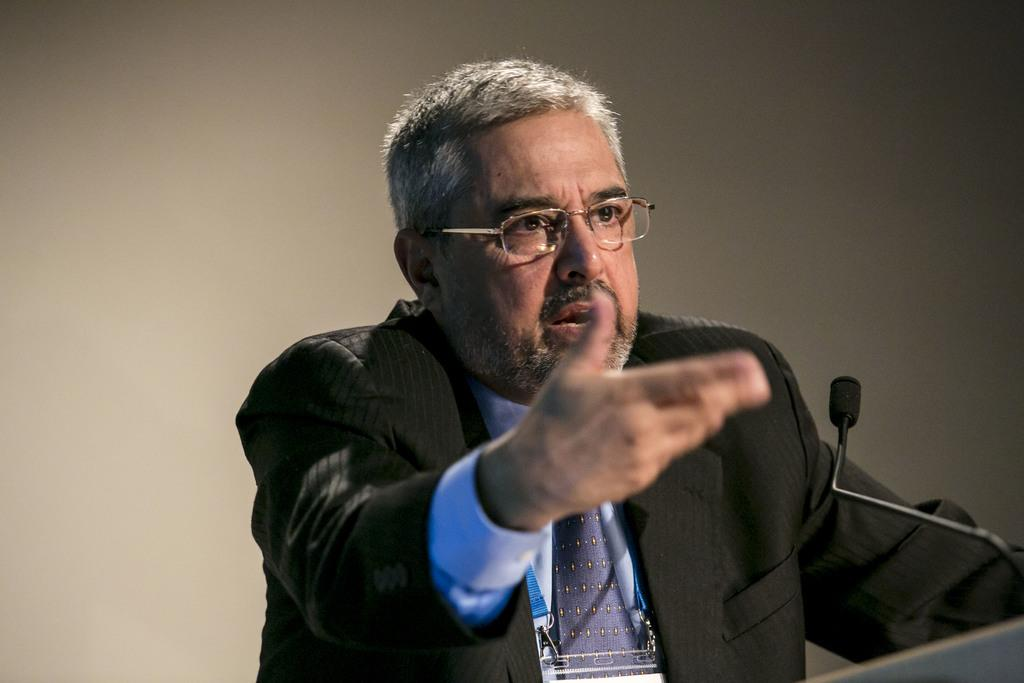What is the person on the right side of the image wearing? The person is wearing a suit. What accessory is the person wearing on their face? The person is wearing a spectacle. What is the person doing in the image? The person is speaking in front of a mic. How is the mic positioned in the image? The mic is attached to a stand. What color is the surface visible in the background of the image? The surface in the background is white. What type of wax is being used to create a sculpture in the image? There is no wax or sculpture present in the image. How many yards of fabric are visible in the image? There is no fabric or yard measurement present in the image. 